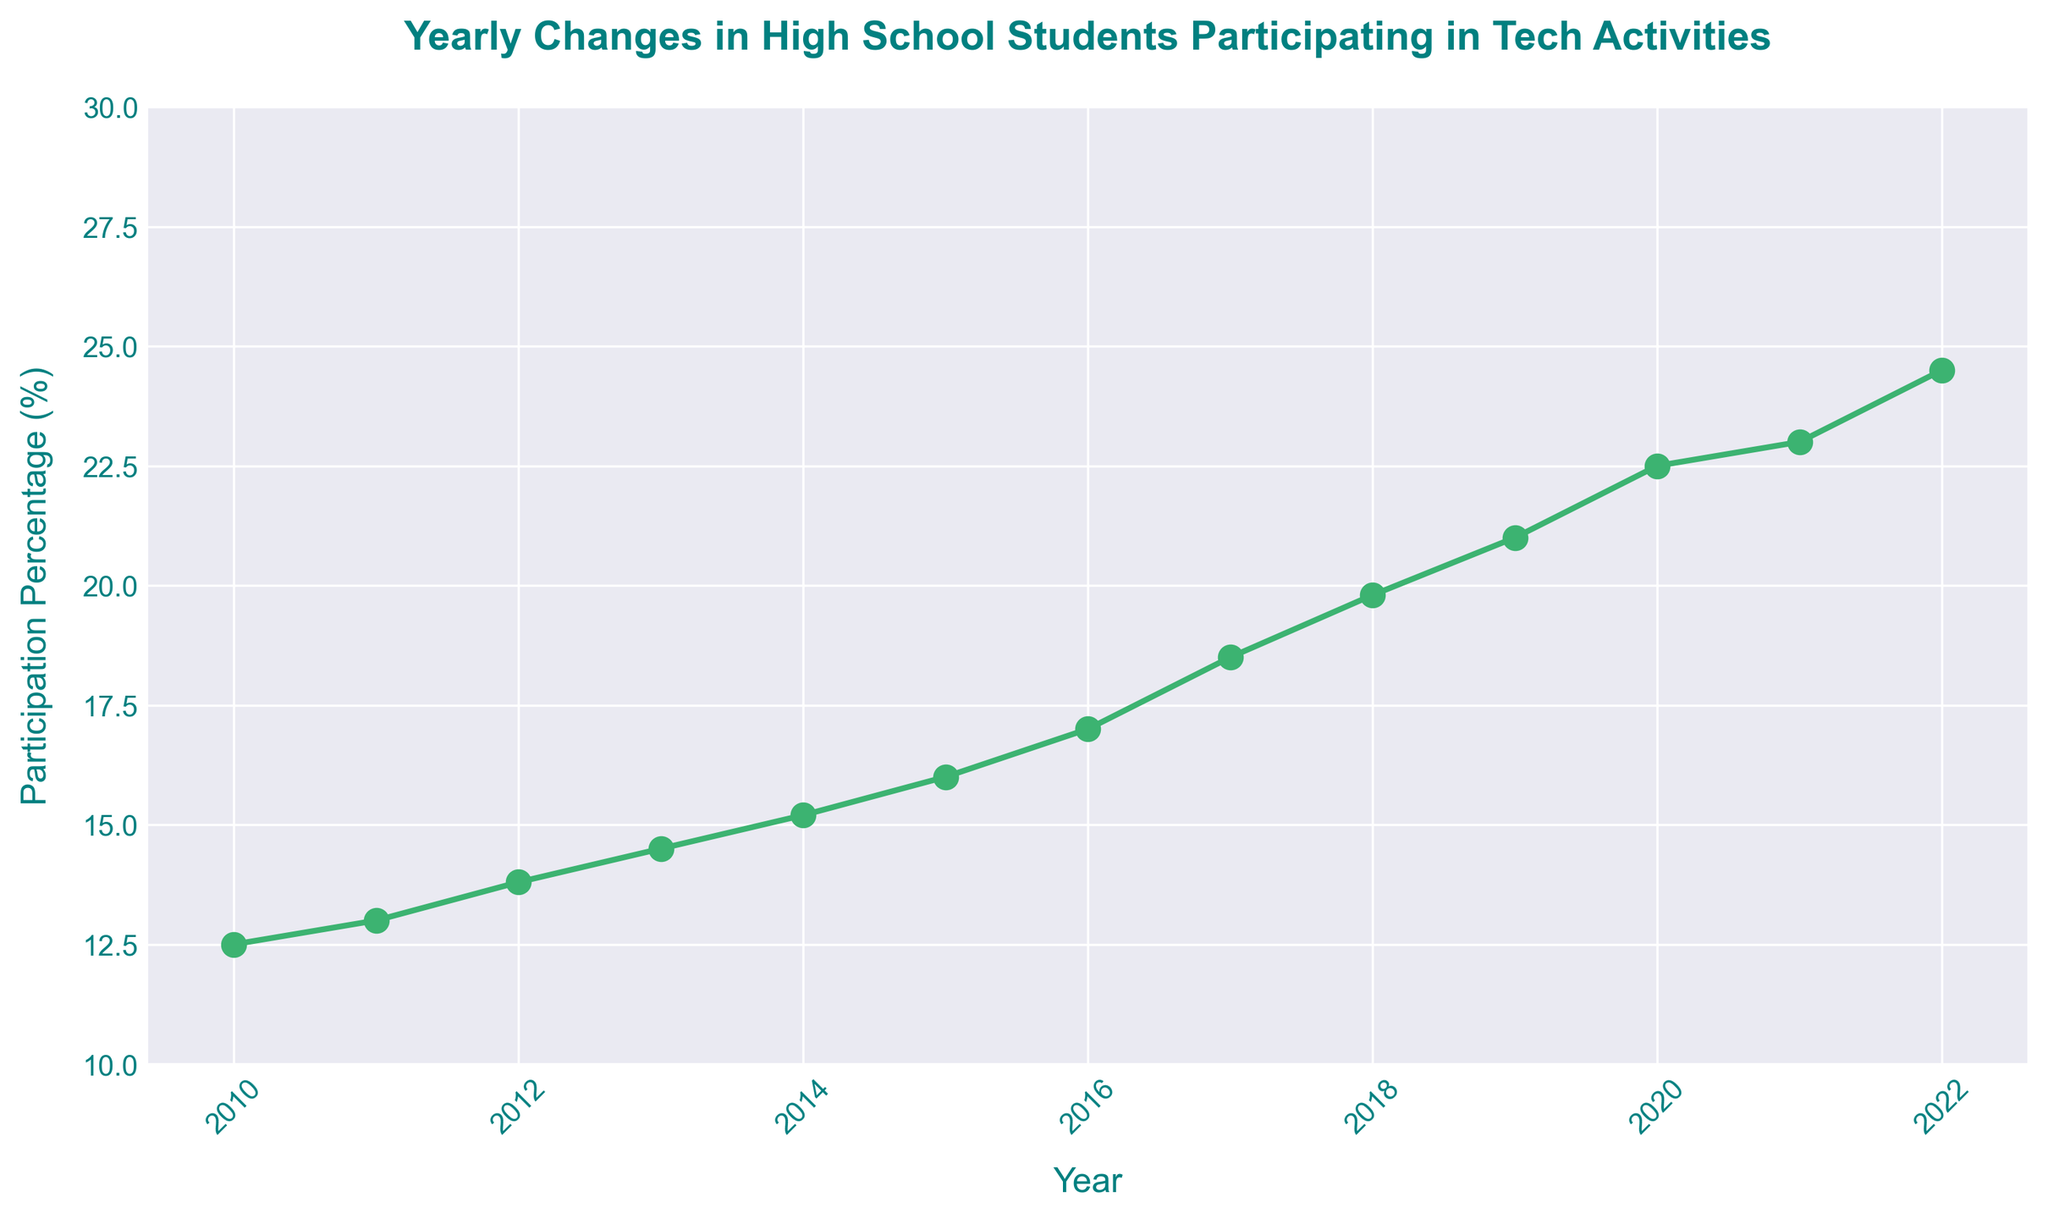What year had the lowest percentage of high school students participating in tech activities? By observing the line chart, the year with the lowest percentage of participation is the starting point of the data. Find the initial year on the x-axis.
Answer: 2010 What is the difference in participation percentage between the years 2012 and 2022? Identify the participation percentages for 2012 and 2022 on the y-axis, then subtract the 2012 value from the 2022 value.
Answer: 10.7% During which years did the percentage increase the most? Observe the y-axis and identify the steepest segments of the line chart, which indicates the largest yearly increase.
Answer: 2016 to 2017 Which year had the highest percentage of participation? Locate the highest point on the line chart and note the corresponding year on the x-axis.
Answer: 2022 What was the average yearly increase in participation percentage from 2010 to 2022? Calculate the total increase from 2010 to 2022 by subtracting the 2010 value from the 2022 value. Then, divide this total increase by the number of years (2022-2010). The formula is (24.5% - 12.5%) / (2022-2010) = 12% / 12 years.
Answer: 1% How many years did it take for the participation percentage to increase from 12.5% to over 20%? Locate 20% on the y-axis and find the corresponding year on the x-axis, then count the number of years from 2010 to that year.
Answer: 9 years (from 2010 to 2019) In which year did the percentage reach just under 25%? Find the point on the line chart closest to but less than 25%, then note the corresponding year on the x-axis.
Answer: 2021 By how much did the participation percentage increase between 2015 and 2017? Identify the percentages for 2015 and 2017. Subtract the 2015 value from the 2017 value.
Answer: 2.5% Which two consecutive years have the smallest difference in participation percentages? Locate the line segments on the chart and identify the shortest vertical distance between consecutive years.
Answer: 2020 to 2021 What is the total increase in participation percentage from the first year to the last year shown in the chart? Subtract the percentage of the first year from the percentage of the last year shown in the chart (2022 percentage - 2010 percentage).
Answer: 12% 